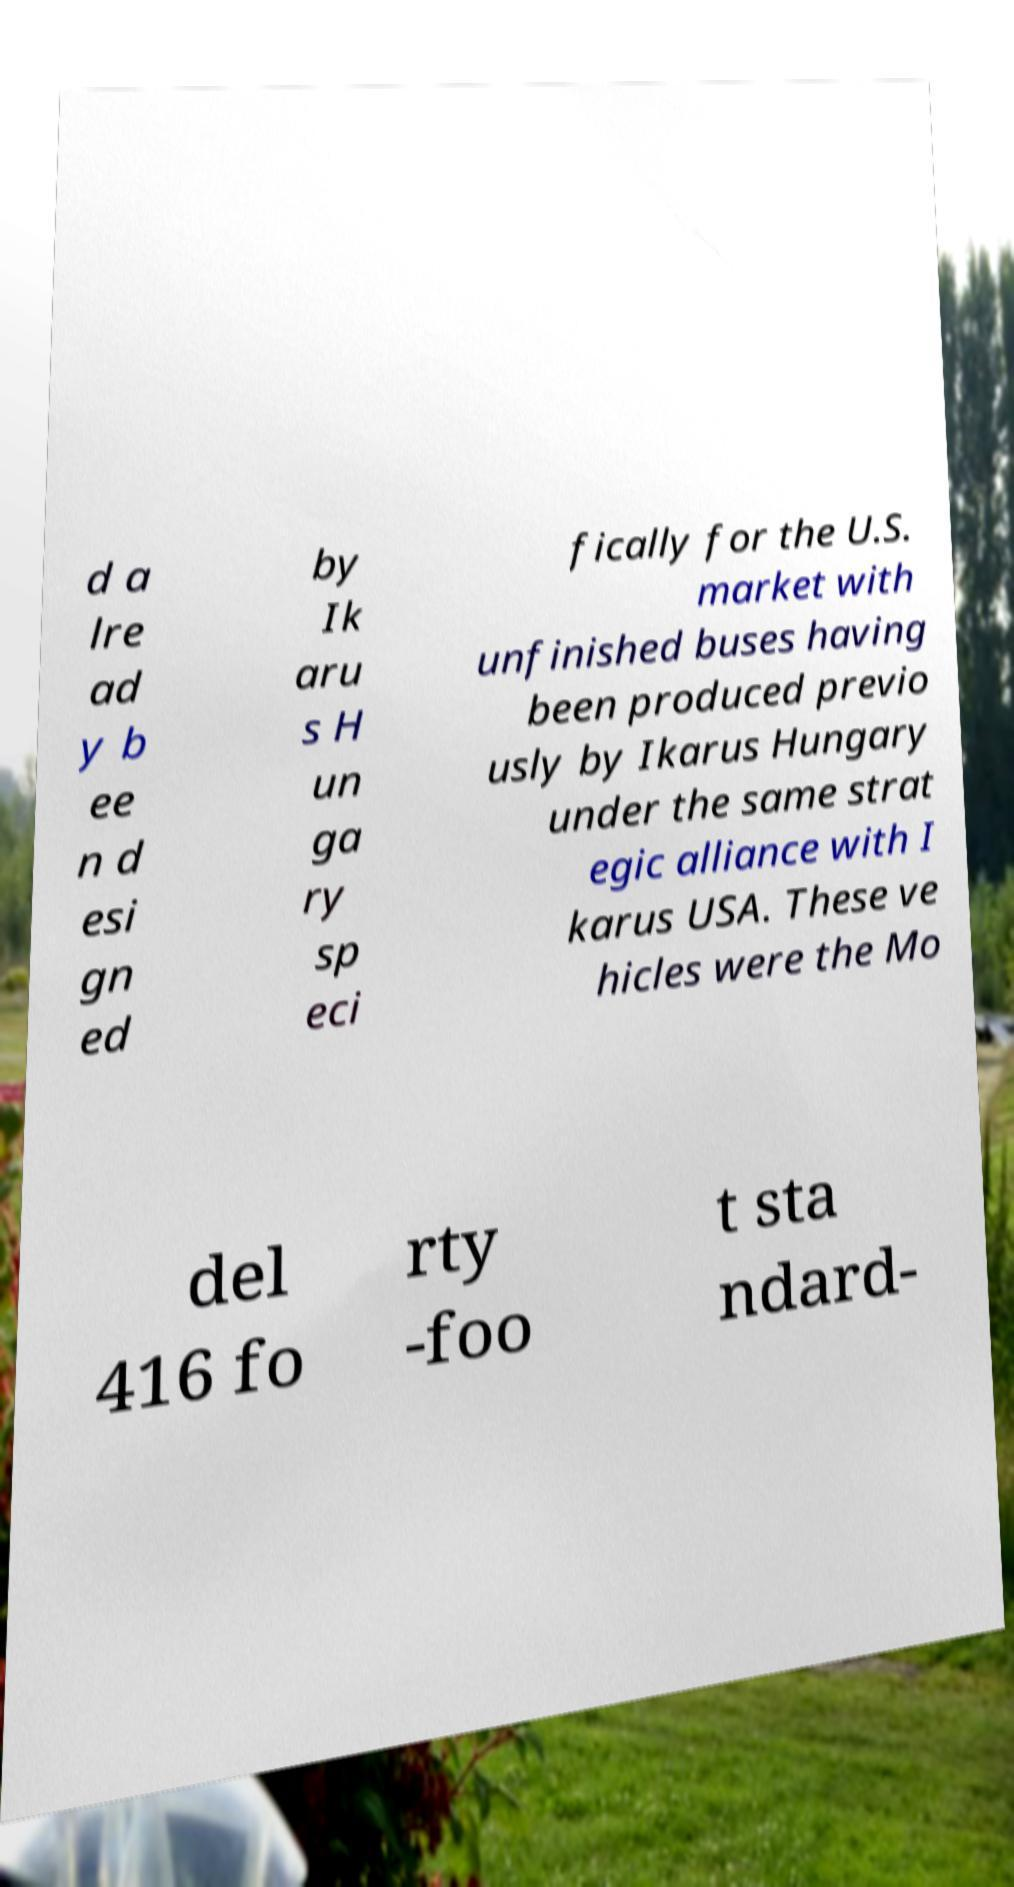Please read and relay the text visible in this image. What does it say? d a lre ad y b ee n d esi gn ed by Ik aru s H un ga ry sp eci fically for the U.S. market with unfinished buses having been produced previo usly by Ikarus Hungary under the same strat egic alliance with I karus USA. These ve hicles were the Mo del 416 fo rty -foo t sta ndard- 